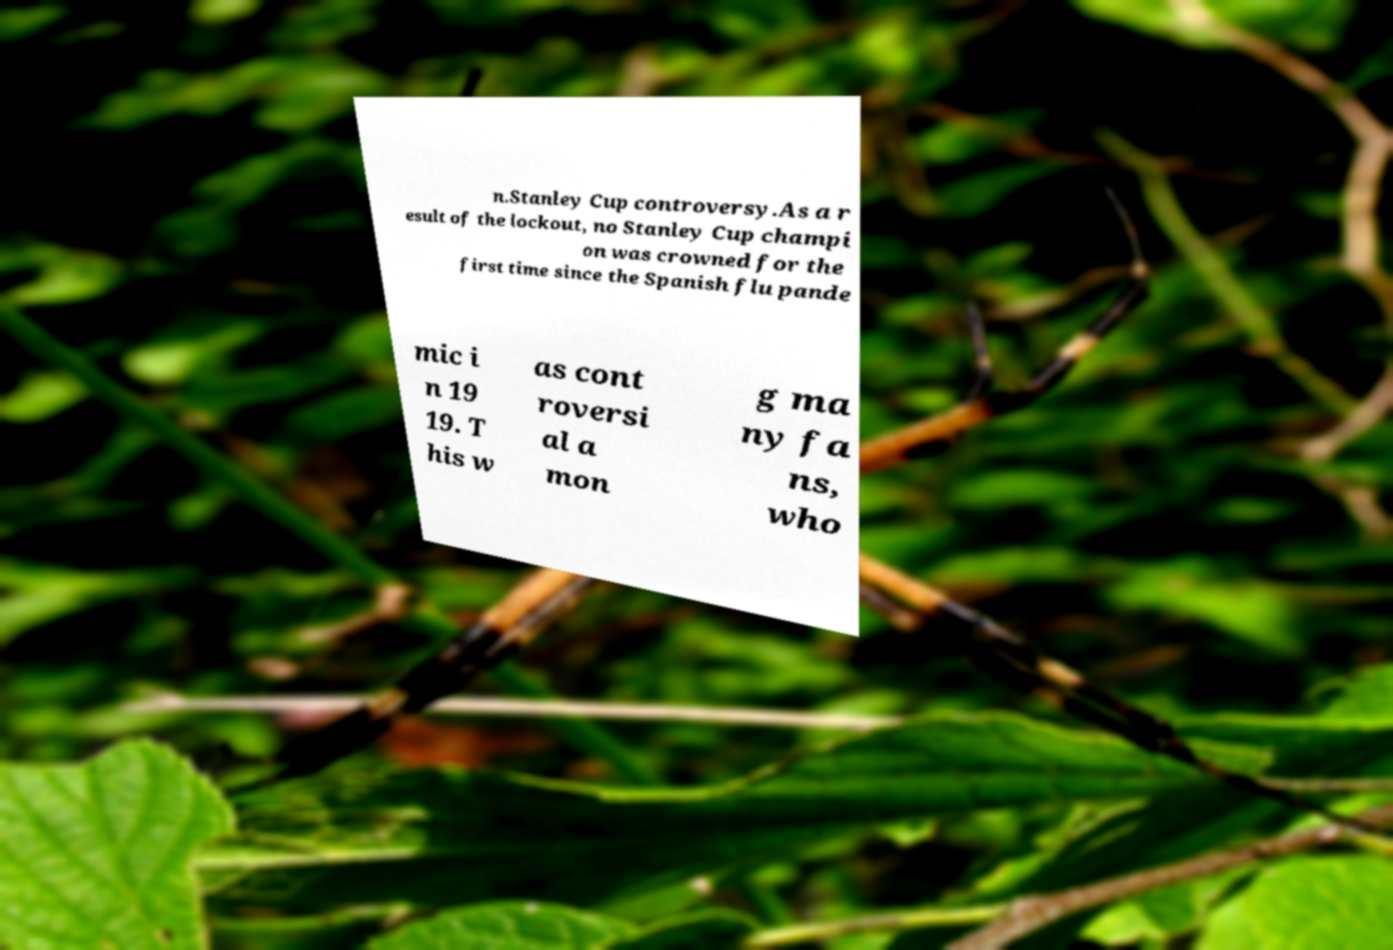Please identify and transcribe the text found in this image. n.Stanley Cup controversy.As a r esult of the lockout, no Stanley Cup champi on was crowned for the first time since the Spanish flu pande mic i n 19 19. T his w as cont roversi al a mon g ma ny fa ns, who 